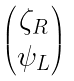<formula> <loc_0><loc_0><loc_500><loc_500>\begin{pmatrix} \zeta _ { R } \\ \psi _ { L } \end{pmatrix}</formula> 